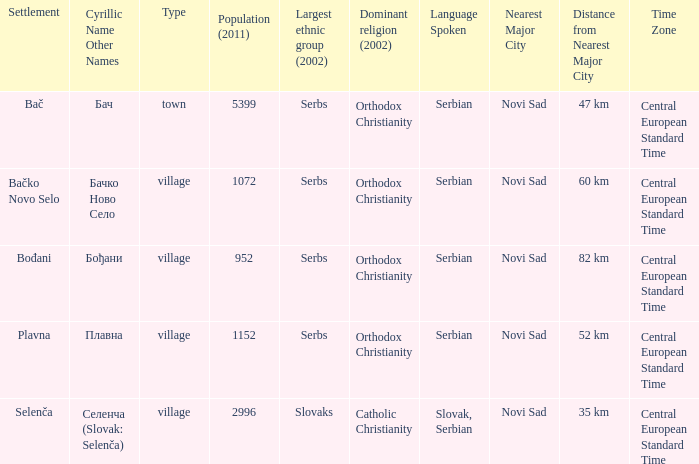What is the second way of writting плавна. Plavna. 